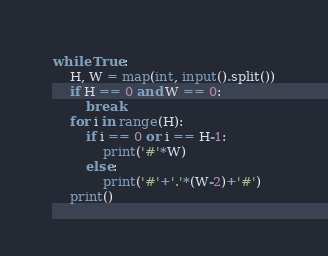<code> <loc_0><loc_0><loc_500><loc_500><_Python_>while True:
    H, W = map(int, input().split())
    if H == 0 and W == 0:
        break
    for i in range(H):
        if i == 0 or i == H-1:
            print('#'*W)
        else:
            print('#'+'.'*(W-2)+'#')
    print()

</code> 